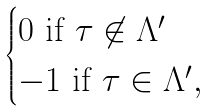Convert formula to latex. <formula><loc_0><loc_0><loc_500><loc_500>\begin{cases} 0 \text { if } \tau \not \in \Lambda ^ { \prime } \\ - 1 \text { if } \tau \in \Lambda ^ { \prime } , \end{cases}</formula> 